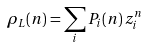<formula> <loc_0><loc_0><loc_500><loc_500>\rho _ { L } ( n ) = \sum _ { i } P _ { i } ( n ) \, z _ { i } ^ { n }</formula> 